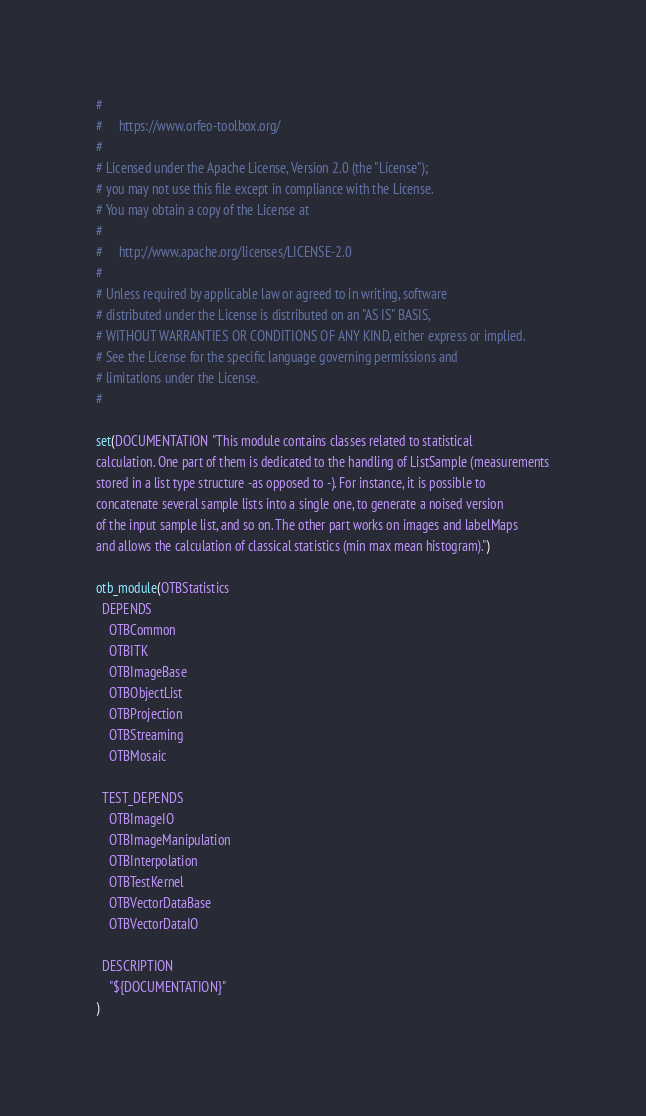Convert code to text. <code><loc_0><loc_0><loc_500><loc_500><_CMake_>#
#     https://www.orfeo-toolbox.org/
#
# Licensed under the Apache License, Version 2.0 (the "License");
# you may not use this file except in compliance with the License.
# You may obtain a copy of the License at
#
#     http://www.apache.org/licenses/LICENSE-2.0
#
# Unless required by applicable law or agreed to in writing, software
# distributed under the License is distributed on an "AS IS" BASIS,
# WITHOUT WARRANTIES OR CONDITIONS OF ANY KIND, either express or implied.
# See the License for the specific language governing permissions and
# limitations under the License.
#

set(DOCUMENTATION "This module contains classes related to statistical
calculation. One part of them is dedicated to the handling of ListSample (measurements
stored in a list type structure -as opposed to -). For instance, it is possible to
concatenate several sample lists into a single one, to generate a noised version
of the input sample list, and so on. The other part works on images and labelMaps
and allows the calculation of classical statistics (min max mean histogram).")

otb_module(OTBStatistics
  DEPENDS
    OTBCommon
    OTBITK
    OTBImageBase
    OTBObjectList
    OTBProjection
    OTBStreaming
    OTBMosaic

  TEST_DEPENDS
    OTBImageIO
    OTBImageManipulation
    OTBInterpolation
    OTBTestKernel
    OTBVectorDataBase
    OTBVectorDataIO

  DESCRIPTION
    "${DOCUMENTATION}"
)
</code> 